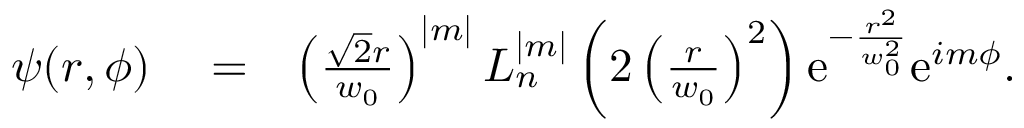Convert formula to latex. <formula><loc_0><loc_0><loc_500><loc_500>\begin{array} { r l r } { \psi ( r , \phi ) } & = } & { \left ( \frac { \sqrt { 2 } r } { w _ { 0 } } \right ) ^ { | m | } L _ { n } ^ { | m | } \left ( 2 \left ( \frac { r } { w _ { 0 } } \right ) ^ { 2 } \right ) e ^ { - \frac { r ^ { 2 } } { w _ { 0 } ^ { 2 } } } e ^ { i m \phi } . } \end{array}</formula> 